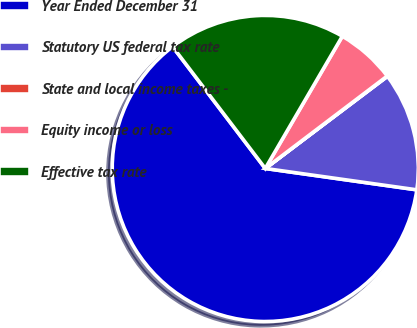Convert chart. <chart><loc_0><loc_0><loc_500><loc_500><pie_chart><fcel>Year Ended December 31<fcel>Statutory US federal tax rate<fcel>State and local income taxes -<fcel>Equity income or loss<fcel>Effective tax rate<nl><fcel>62.42%<fcel>12.51%<fcel>0.04%<fcel>6.28%<fcel>18.75%<nl></chart> 